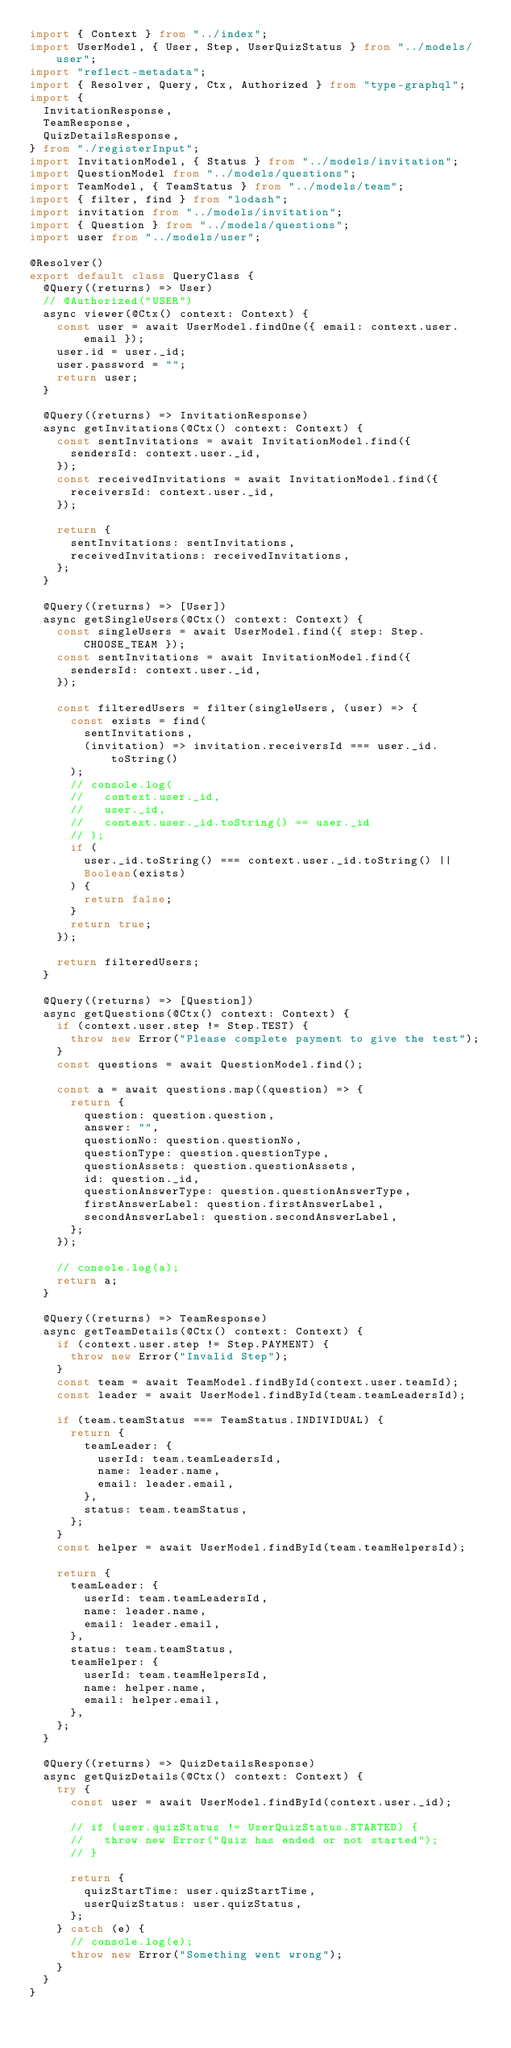Convert code to text. <code><loc_0><loc_0><loc_500><loc_500><_TypeScript_>import { Context } from "../index";
import UserModel, { User, Step, UserQuizStatus } from "../models/user";
import "reflect-metadata";
import { Resolver, Query, Ctx, Authorized } from "type-graphql";
import {
  InvitationResponse,
  TeamResponse,
  QuizDetailsResponse,
} from "./registerInput";
import InvitationModel, { Status } from "../models/invitation";
import QuestionModel from "../models/questions";
import TeamModel, { TeamStatus } from "../models/team";
import { filter, find } from "lodash";
import invitation from "../models/invitation";
import { Question } from "../models/questions";
import user from "../models/user";

@Resolver()
export default class QueryClass {
  @Query((returns) => User)
  // @Authorized("USER")
  async viewer(@Ctx() context: Context) {
    const user = await UserModel.findOne({ email: context.user.email });
    user.id = user._id;
    user.password = "";
    return user;
  }

  @Query((returns) => InvitationResponse)
  async getInvitations(@Ctx() context: Context) {
    const sentInvitations = await InvitationModel.find({
      sendersId: context.user._id,
    });
    const receivedInvitations = await InvitationModel.find({
      receiversId: context.user._id,
    });

    return {
      sentInvitations: sentInvitations,
      receivedInvitations: receivedInvitations,
    };
  }

  @Query((returns) => [User])
  async getSingleUsers(@Ctx() context: Context) {
    const singleUsers = await UserModel.find({ step: Step.CHOOSE_TEAM });
    const sentInvitations = await InvitationModel.find({
      sendersId: context.user._id,
    });

    const filteredUsers = filter(singleUsers, (user) => {
      const exists = find(
        sentInvitations,
        (invitation) => invitation.receiversId === user._id.toString()
      );
      // console.log(
      //   context.user._id,
      //   user._id,
      //   context.user._id.toString() == user._id
      // );
      if (
        user._id.toString() === context.user._id.toString() ||
        Boolean(exists)
      ) {
        return false;
      }
      return true;
    });

    return filteredUsers;
  }

  @Query((returns) => [Question])
  async getQuestions(@Ctx() context: Context) {
    if (context.user.step != Step.TEST) {
      throw new Error("Please complete payment to give the test");
    }
    const questions = await QuestionModel.find();

    const a = await questions.map((question) => {
      return {
        question: question.question,
        answer: "",
        questionNo: question.questionNo,
        questionType: question.questionType,
        questionAssets: question.questionAssets,
        id: question._id,
        questionAnswerType: question.questionAnswerType,
        firstAnswerLabel: question.firstAnswerLabel,
        secondAnswerLabel: question.secondAnswerLabel,
      };
    });

    // console.log(a);
    return a;
  }

  @Query((returns) => TeamResponse)
  async getTeamDetails(@Ctx() context: Context) {
    if (context.user.step != Step.PAYMENT) {
      throw new Error("Invalid Step");
    }
    const team = await TeamModel.findById(context.user.teamId);
    const leader = await UserModel.findById(team.teamLeadersId);

    if (team.teamStatus === TeamStatus.INDIVIDUAL) {
      return {
        teamLeader: {
          userId: team.teamLeadersId,
          name: leader.name,
          email: leader.email,
        },
        status: team.teamStatus,
      };
    }
    const helper = await UserModel.findById(team.teamHelpersId);

    return {
      teamLeader: {
        userId: team.teamLeadersId,
        name: leader.name,
        email: leader.email,
      },
      status: team.teamStatus,
      teamHelper: {
        userId: team.teamHelpersId,
        name: helper.name,
        email: helper.email,
      },
    };
  }

  @Query((returns) => QuizDetailsResponse)
  async getQuizDetails(@Ctx() context: Context) {
    try {
      const user = await UserModel.findById(context.user._id);

      // if (user.quizStatus != UserQuizStatus.STARTED) {
      //   throw new Error("Quiz has ended or not started");
      // }

      return {
        quizStartTime: user.quizStartTime,
        userQuizStatus: user.quizStatus,
      };
    } catch (e) {
      // console.log(e);
      throw new Error("Something went wrong");
    }
  }
}
</code> 